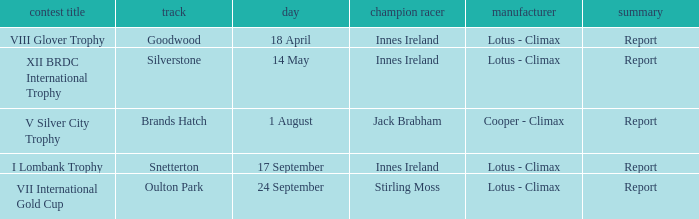What circuit did Innes Ireland win at for the I lombank trophy? Snetterton. Help me parse the entirety of this table. {'header': ['contest title', 'track', 'day', 'champion racer', 'manufacturer', 'summary'], 'rows': [['VIII Glover Trophy', 'Goodwood', '18 April', 'Innes Ireland', 'Lotus - Climax', 'Report'], ['XII BRDC International Trophy', 'Silverstone', '14 May', 'Innes Ireland', 'Lotus - Climax', 'Report'], ['V Silver City Trophy', 'Brands Hatch', '1 August', 'Jack Brabham', 'Cooper - Climax', 'Report'], ['I Lombank Trophy', 'Snetterton', '17 September', 'Innes Ireland', 'Lotus - Climax', 'Report'], ['VII International Gold Cup', 'Oulton Park', '24 September', 'Stirling Moss', 'Lotus - Climax', 'Report']]} 